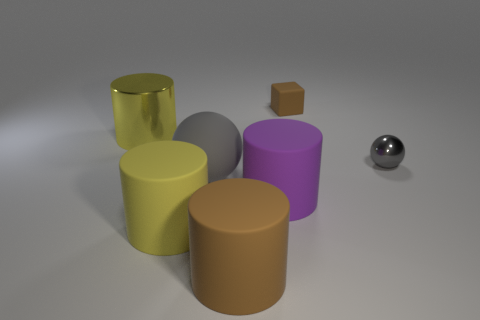Add 2 tiny spheres. How many objects exist? 9 Subtract all spheres. How many objects are left? 5 Subtract all purple shiny cylinders. Subtract all tiny gray things. How many objects are left? 6 Add 5 small things. How many small things are left? 7 Add 7 big shiny cubes. How many big shiny cubes exist? 7 Subtract 1 purple cylinders. How many objects are left? 6 